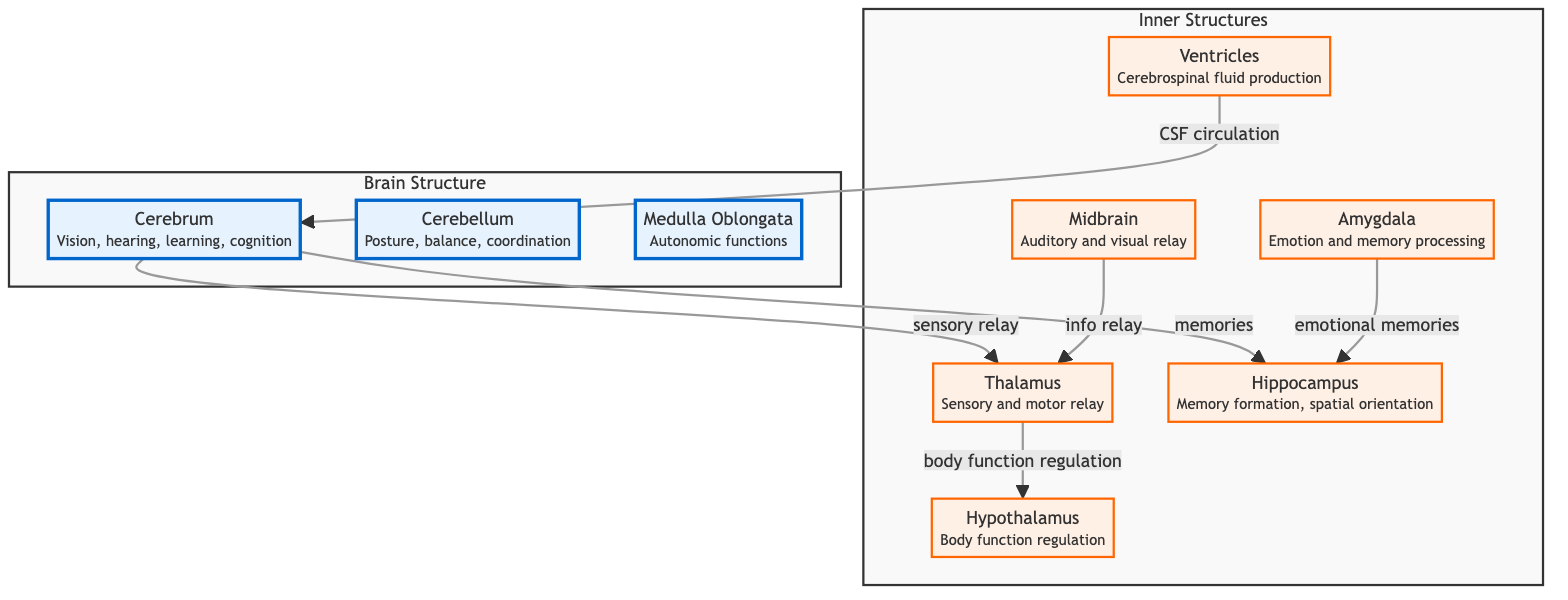What are the main nodes in the diagram? The main nodes are the cerebrum, cerebellum, and medulla oblongata. These nodes are distinguished with a different color and represent the primary structures of the brain.
Answer: cerebrum, cerebellum, medulla oblongata How many subnodes are shown in the diagram? There are six subnodes in the diagram, which include the midbrain, thalamus, hypothalamus, hippocampus, amygdala, and ventricles. These nodes are connected to the main nodes and represent inner structures of the brain.
Answer: 6 Which structure is responsible for memory formation? The hippocampus is labeled as responsible for memory formation and spatial orientation. It is connected to the cerebrum and the amygdala, showing its integral role in memory processes.
Answer: hippocampus What is the relationship between the thalamus and the hypothalamus in the diagram? The thalamus is a sensory and motor relay and has a direct connection to the hypothalamus, indicating that it plays a role in body function regulation. This relationship is shown in a directional arrow from thalamus to hypothalamus.
Answer: body function regulation Which structures are connected to the cerebrum? The cerebrum connects to the hippocampus (via memories) and the thalamus (via sensory relay). This shows how the cerebrum interacts with both memory and sensory processing functions.
Answer: hippocampus, thalamus What is the function of the ventricles as displayed in the diagram? The diagram indicates that the ventricles are responsible for cerebrospinal fluid production and circulation, which is essential for the protection and functioning of the brain.
Answer: cerebrospinal fluid production What connects amygdala and hippocampus? The arrow indicates that the amygdala is connected to the hippocampus through the aspect of emotional memories, highlighting the relationship between emotion and memory processing.
Answer: emotional memories How many major parts form the brain structure in the diagram? The brain structure in the diagram is formed by three major parts: cerebrum, cerebellum, and medulla oblongata. These parts are grouped under a subgraph labeled "Brain Structure".
Answer: 3 What function does the midbrain serve as per the diagram? The midbrain serves as an auditory and visual relay. It connects information between sensory input (auditory and visual) and the thalamus, which processes that information further.
Answer: auditory and visual relay What does the cerebrospinal fluid do according to the diagram? The cerebrospinal fluid, produced by the ventricles, circulates through the cerebrum, providing protection and nourishment to the brain structures. This function is highlighted by its connection to the cerebrum in the diagram.
Answer: CSF circulation 